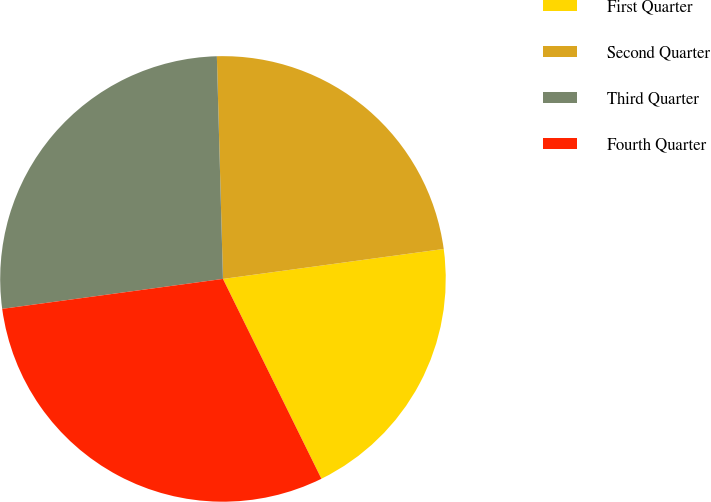Convert chart. <chart><loc_0><loc_0><loc_500><loc_500><pie_chart><fcel>First Quarter<fcel>Second Quarter<fcel>Third Quarter<fcel>Fourth Quarter<nl><fcel>19.86%<fcel>23.29%<fcel>26.71%<fcel>30.14%<nl></chart> 